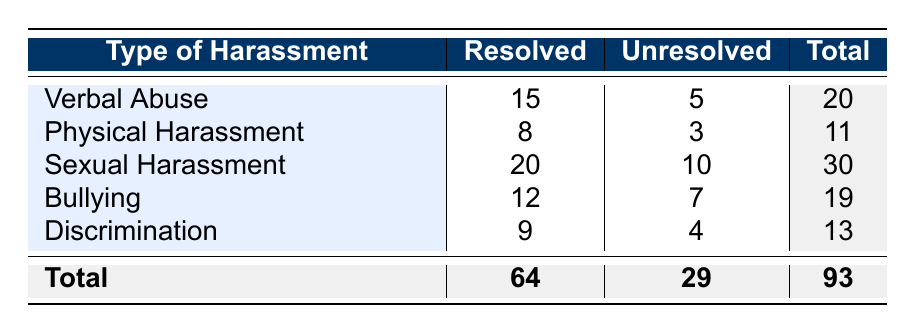What is the number of cases for verbal abuse that were resolved? According to the table, there are 15 cases of verbal abuse that were resolved.
Answer: 15 What is the total number of unresolved cases across all types of harassment? By summing the unresolved cases from each type of harassment: 5 (Verbal Abuse) + 3 (Physical Harassment) + 10 (Sexual Harassment) + 7 (Bullying) + 4 (Discrimination) = 29.
Answer: 29 Is there a higher number of resolved cases for sexual harassment compared to physical harassment? There are 20 resolved cases for sexual harassment and 8 for physical harassment. Since 20 is greater than 8, the statement is true.
Answer: Yes How many more cases were resolved for bullying than for discrimination? The number of resolved cases for bullying is 12, and for discrimination, it is 9. The difference is 12 - 9 = 3.
Answer: 3 What is the total number of cases for physical harassment? The total for physical harassment is calculated by adding both resolved and unresolved cases: 8 (Resolved) + 3 (Unresolved) = 11.
Answer: 11 Are there more resolved cases overall than unresolved cases across all types of harassment? The total resolved cases are 64, and the unresolved cases are 29. Since 64 is greater than 29, there are more resolved cases.
Answer: Yes What is the proportion of resolved cases to total cases for verbal abuse? The total cases for verbal abuse is 20 (15 resolved and 5 unresolved). The proportion of resolved cases is 15/20 = 0.75.
Answer: 0.75 What is the average number of unresolved cases for the types of harassment listed? There are five types of harassment with unresolved cases: 5, 3, 10, 7, and 4. Summing these gives 29, and dividing by 5 gives an average of 29/5 = 5.8.
Answer: 5.8 